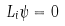<formula> <loc_0><loc_0><loc_500><loc_500>L _ { i } \psi = 0</formula> 